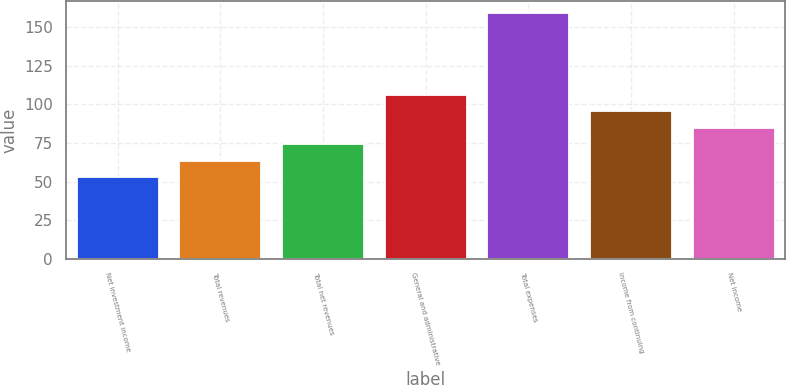Convert chart to OTSL. <chart><loc_0><loc_0><loc_500><loc_500><bar_chart><fcel>Net investment income<fcel>Total revenues<fcel>Total net revenues<fcel>General and administrative<fcel>Total expenses<fcel>Income from continuing<fcel>Net income<nl><fcel>53<fcel>63.6<fcel>74.2<fcel>106<fcel>159<fcel>95.4<fcel>84.8<nl></chart> 